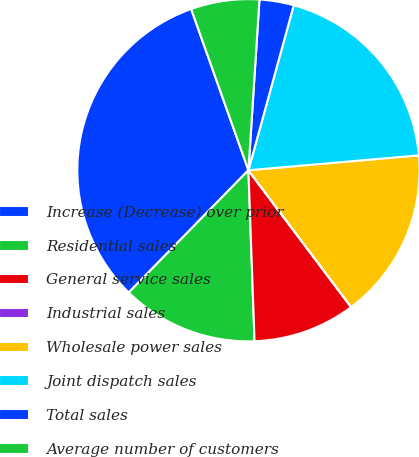<chart> <loc_0><loc_0><loc_500><loc_500><pie_chart><fcel>Increase (Decrease) over prior<fcel>Residential sales<fcel>General service sales<fcel>Industrial sales<fcel>Wholesale power sales<fcel>Joint dispatch sales<fcel>Total sales<fcel>Average number of customers<nl><fcel>32.24%<fcel>12.9%<fcel>9.68%<fcel>0.01%<fcel>16.13%<fcel>19.35%<fcel>3.24%<fcel>6.46%<nl></chart> 